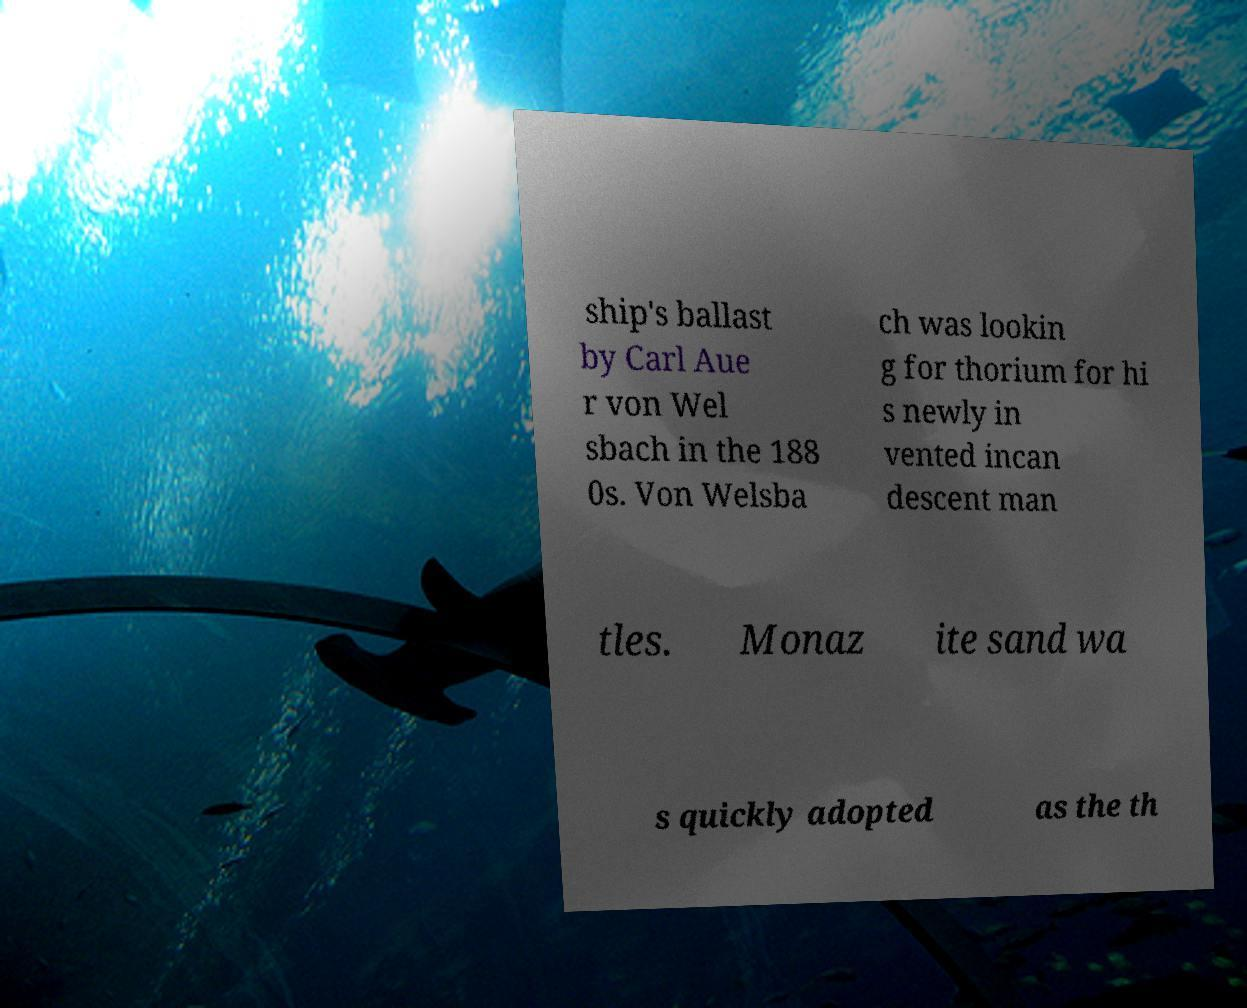Can you read and provide the text displayed in the image?This photo seems to have some interesting text. Can you extract and type it out for me? ship's ballast by Carl Aue r von Wel sbach in the 188 0s. Von Welsba ch was lookin g for thorium for hi s newly in vented incan descent man tles. Monaz ite sand wa s quickly adopted as the th 